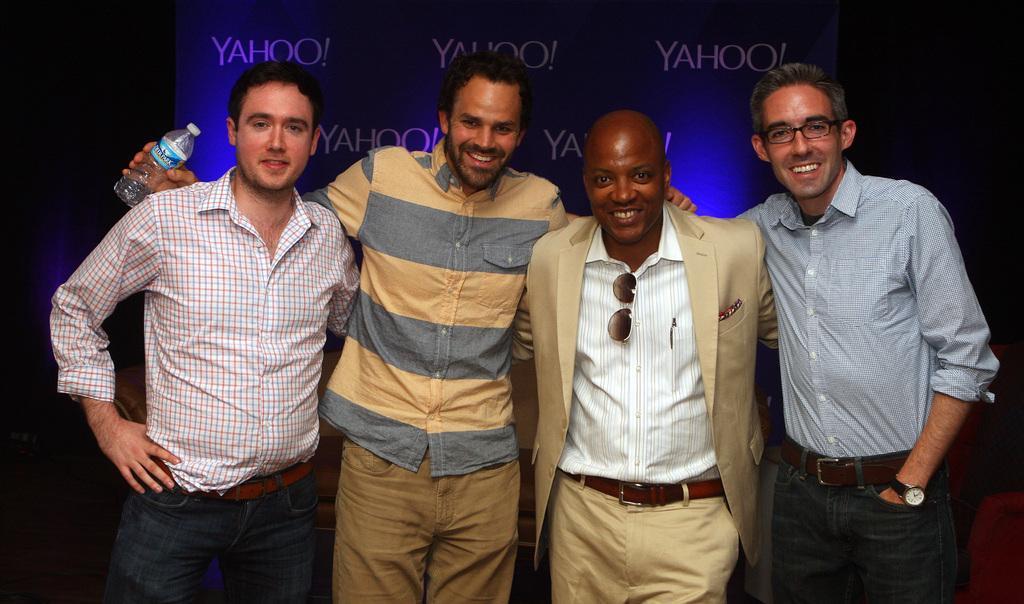Could you give a brief overview of what you see in this image? In this image, we can see people standing and one of them is holding an object and some are wearing glasses. In the background, there is a screen. 